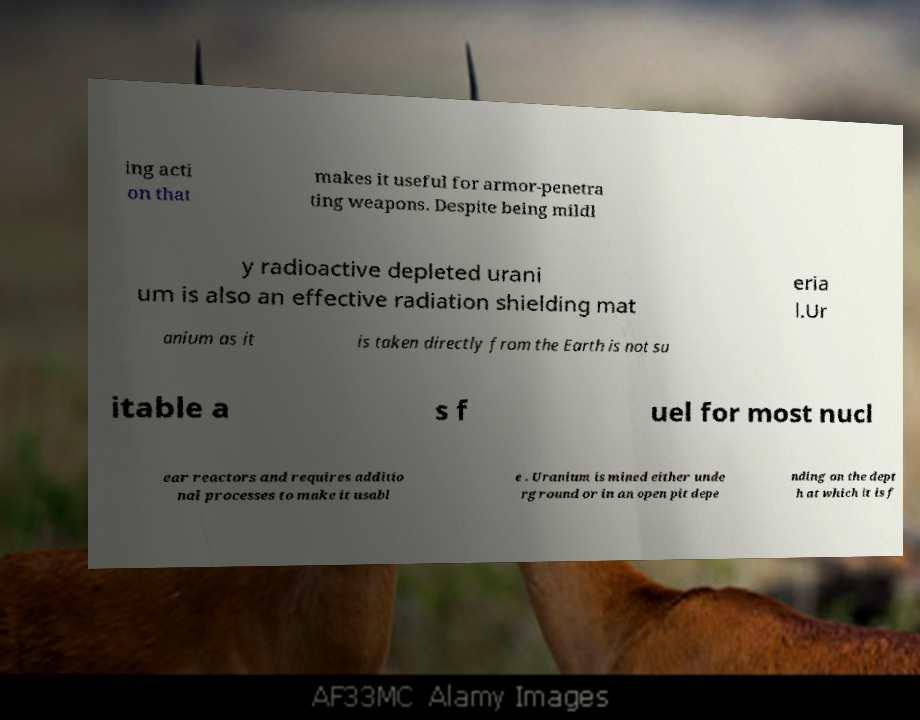There's text embedded in this image that I need extracted. Can you transcribe it verbatim? ing acti on that makes it useful for armor-penetra ting weapons. Despite being mildl y radioactive depleted urani um is also an effective radiation shielding mat eria l.Ur anium as it is taken directly from the Earth is not su itable a s f uel for most nucl ear reactors and requires additio nal processes to make it usabl e . Uranium is mined either unde rground or in an open pit depe nding on the dept h at which it is f 